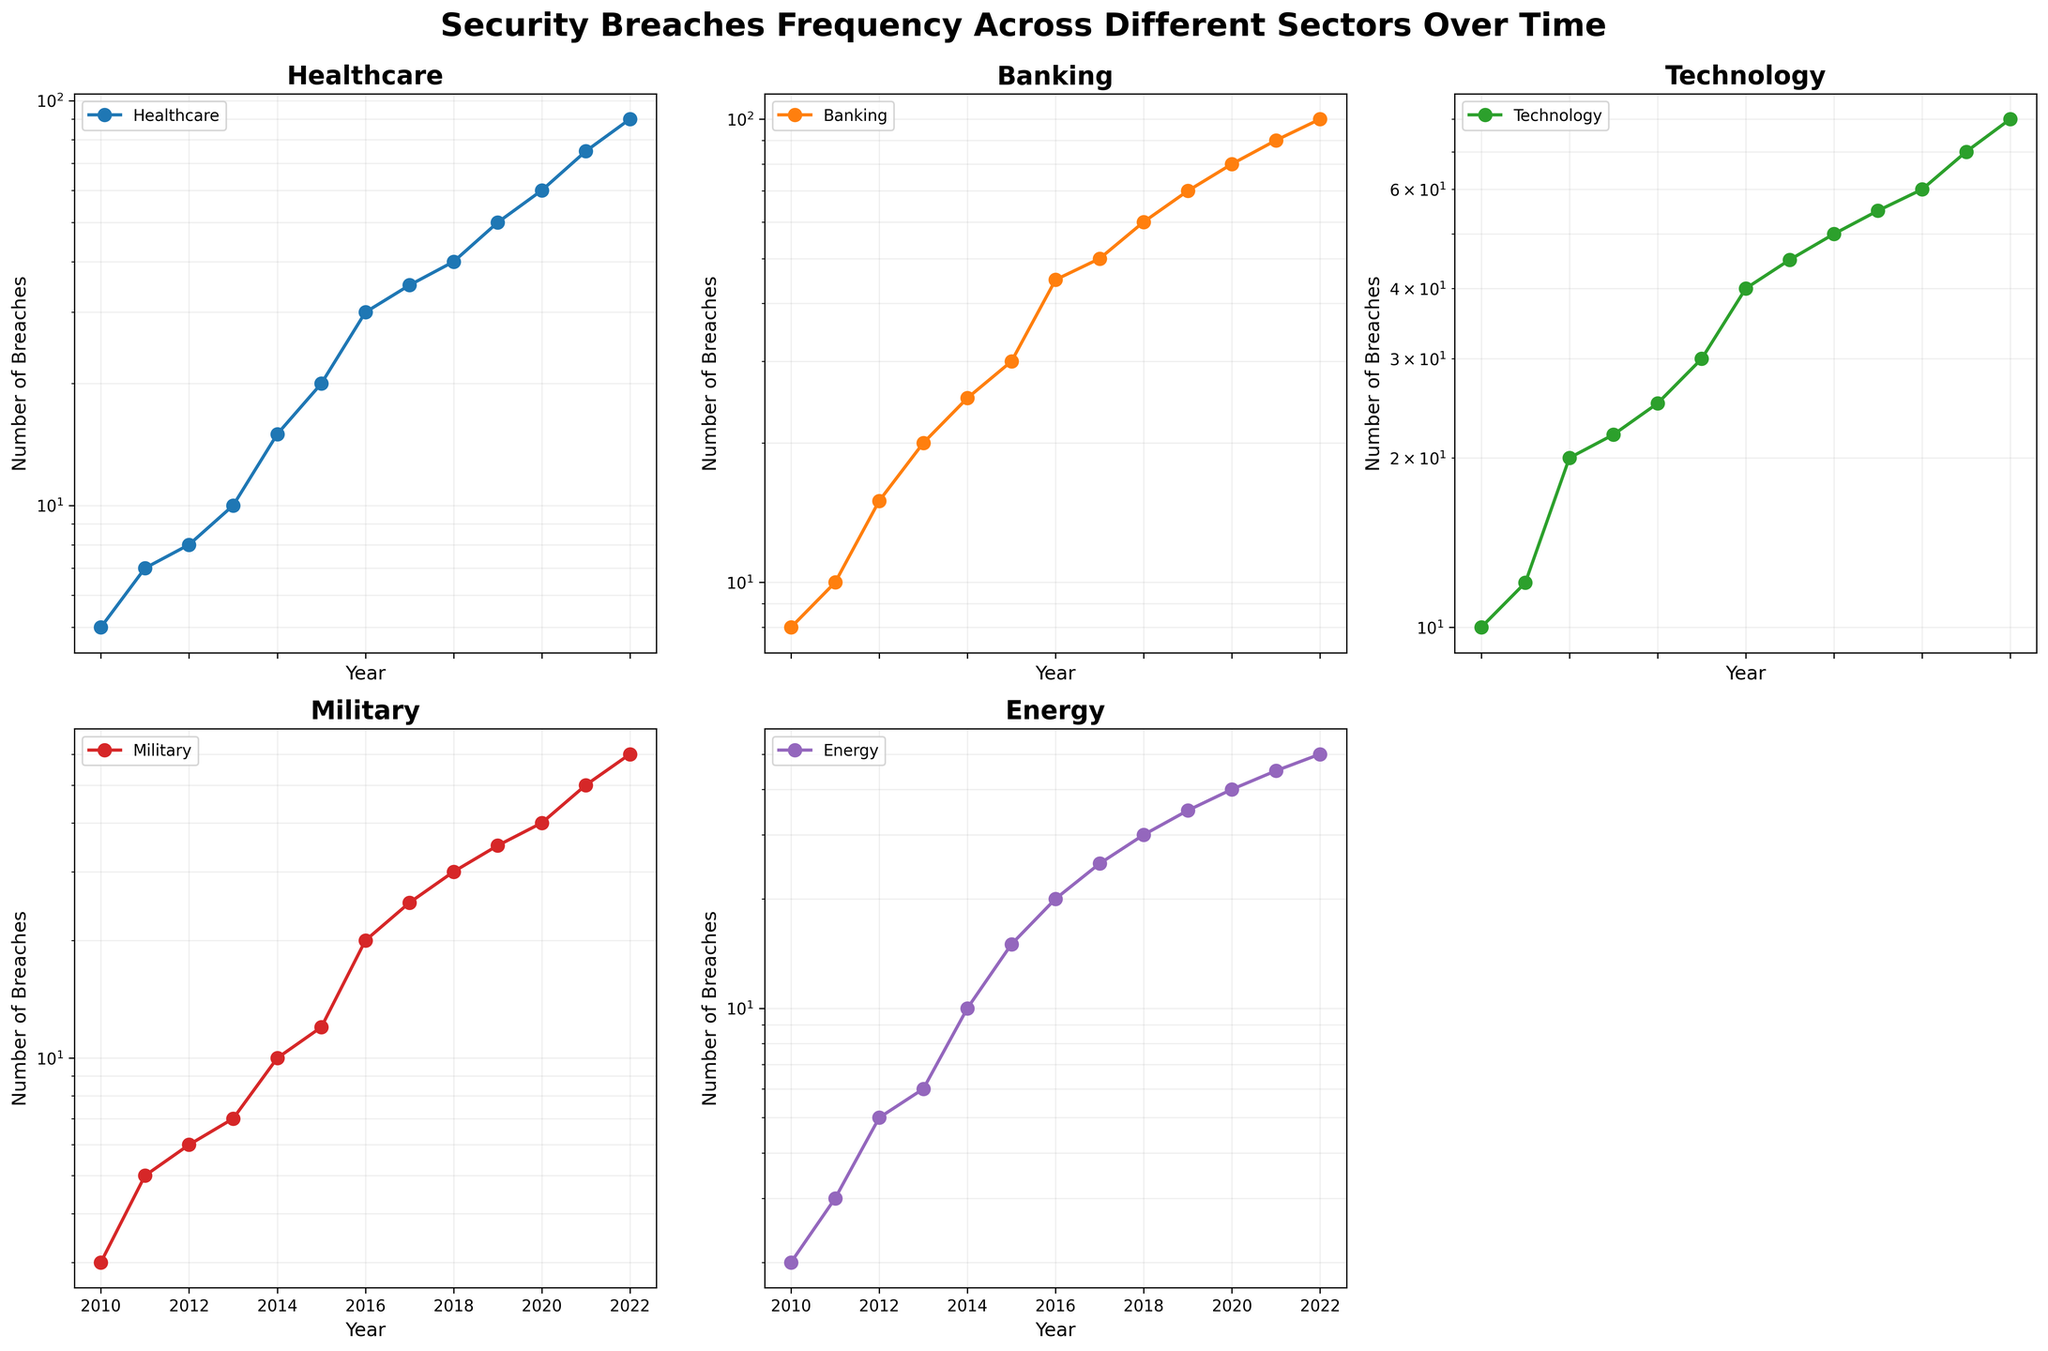what year has the highest number of security breaches in the Technology sector? Look at the Technology subplot and check the year with the highest point on the logarithmic scale. The year with the highest point is 2022.
Answer: 2022 which sector had fewer security breaches in 2015, Healthcare or Technology? Compare the height of the points for Healthcare and Technology in the year 2015. Healthcare has 20 breaches, and Technology has 30 breaches.
Answer: Healthcare by how many breaches did the number of security breaches in the Energy sector increase from 2010 to 2022? Find the number of breaches in the Energy sector in 2010 and 2022, then subtract the 2010 value from the 2022 value. The increase is 50 - 2 = 48.
Answer: 48 which sector saw the most significant increase in the number of security breaches from 2010 to 2022? Calculate the differences for each sector from 2010 to 2022. The differences are: Healthcare (85), Banking (92), Technology (70), Military (57), Energy (48). Banking has the largest increase.
Answer: Banking what is the overall trend in the number of security breaches in the Military sector over time? Examine the Military sector subplot and observe if the number of breaches increases, decreases, or remains constant over the years. The trend shows a consistent increase.
Answer: Increasing how many years did the Healthcare sector show a higher frequency of security breaches than the Energy sector? For each year, compare the frequencies in the Healthcare and Energy sectors and count the number of years where Healthcare had a higher value. Healthcare had higher breaches in 2010, 2011, 2012, 2013, 2014, 2015, 2016, 2017, 2018, 2019, 2020, 2021, and 2022.
Answer: 13 what is the average number of security breaches for the Banking sector between 2010 and 2022? Sum up the breaches in the Banking sector from 2010 to 2022 and divide by the number of years (13). The sum is 8 + 10 + 15 + 20 + 25 + 30 + 45 + 50 + 60 + 70 + 80 + 90 + 100 = 603. The average = 603 / 13 ≈ 46.38.
Answer: 46.38 which sector had the smallest number of breaches in 2010, and what was that number? Look at the initial year (2010) for all sectors and determine which one has the lowest point and its corresponding number. The Military sector had the smallest number with 3 breaches.
Answer: Military, 3 did the Technology sector ever show a decrease in the number of breaches from one year to the next? Examine the Technology sector subplot and verify if there’s any year where the number of breaches is less than the previous year. The number of breaches consistently increases every year.
Answer: No if you sum up the breaches for the Military and Banking sectors in 2020, what is the result? Add the breaches for Military and Banking in 2020. The sum is 40 (Military) + 80 (Banking) = 120.
Answer: 120 